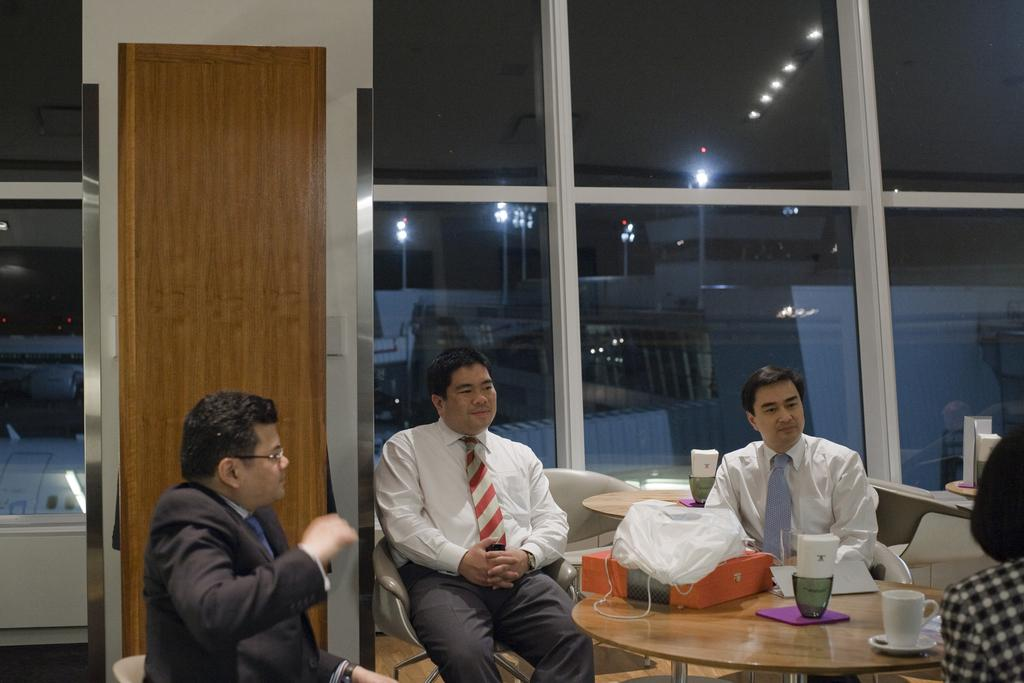How many people are in the image? There is a group of people in the image. What are the people in the image doing? The people are sitting. What is in front of the group of people? There is a table in front of the group. What items can be seen on the table? There is a coffee mug and tissues on the table. Can you describe the position of the woman in the image? There is a woman sitting on the left side of the group. What type of flowers are on the table in the image? There are no flowers present on the table in the image. 